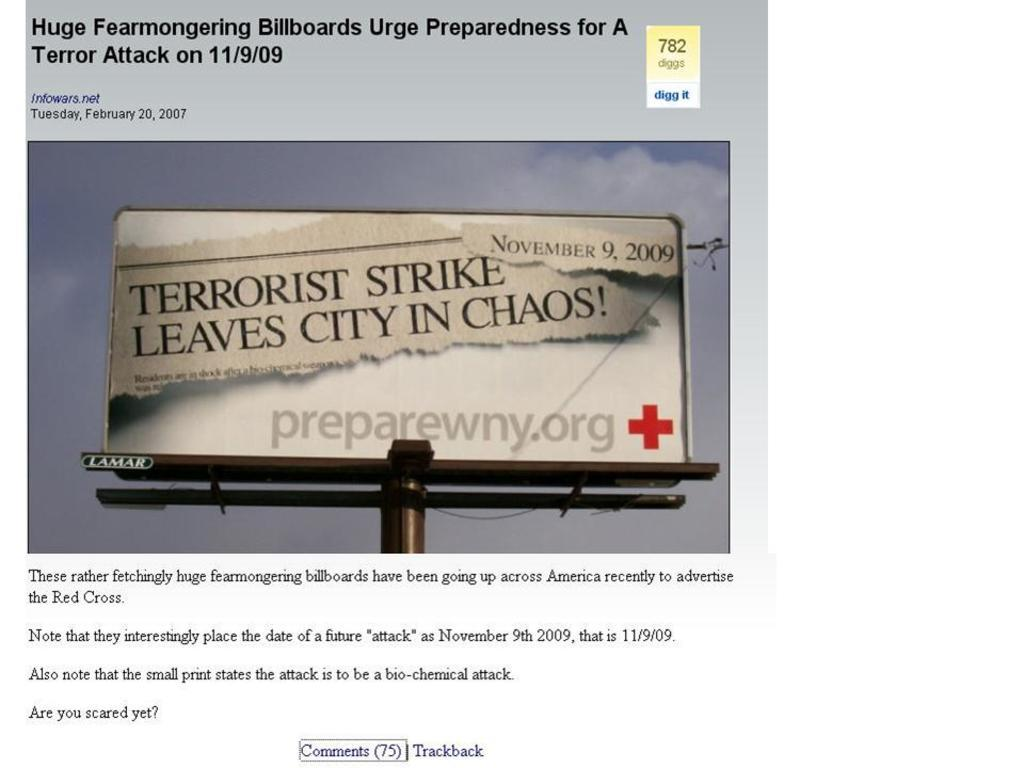<image>
Relay a brief, clear account of the picture shown. Large Billboard sign that is mentioning about a Terrorist Strike that leaves a city in chaos. 